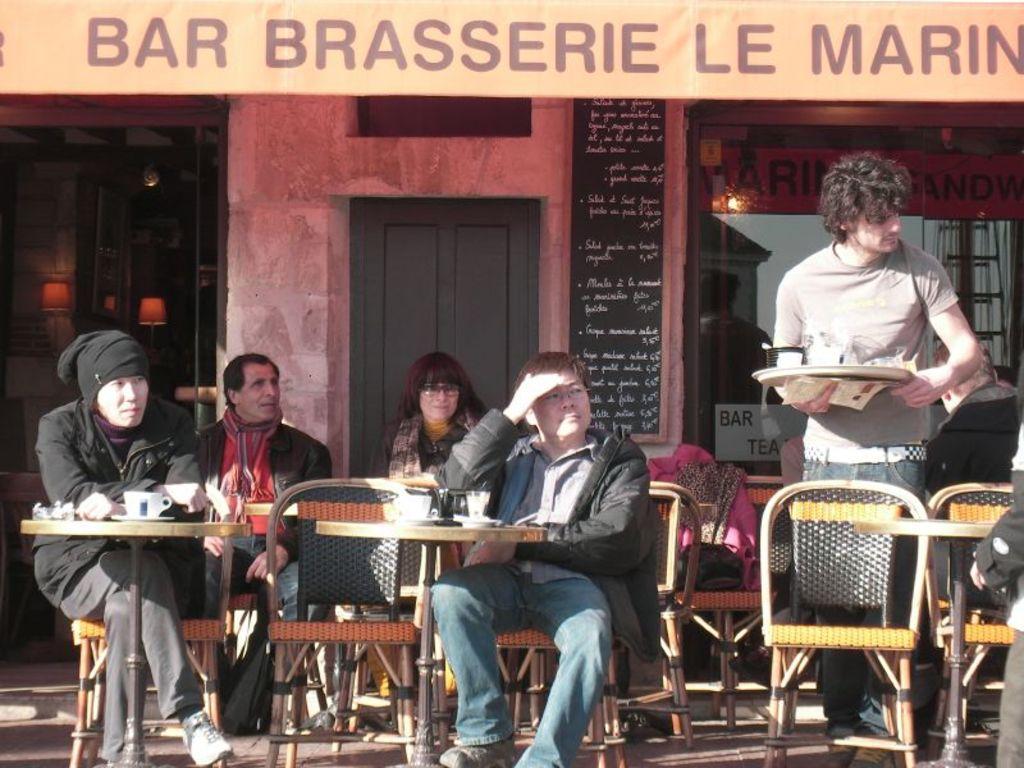In one or two sentences, can you explain what this image depicts? In this picture there are five people. Four of them are sitting on the chair and the one is standing with holding a plate in his hand. In the background there is a door, beside the door there is a menu. To the left side there is a store. And to the right side there is another store with a glass. 